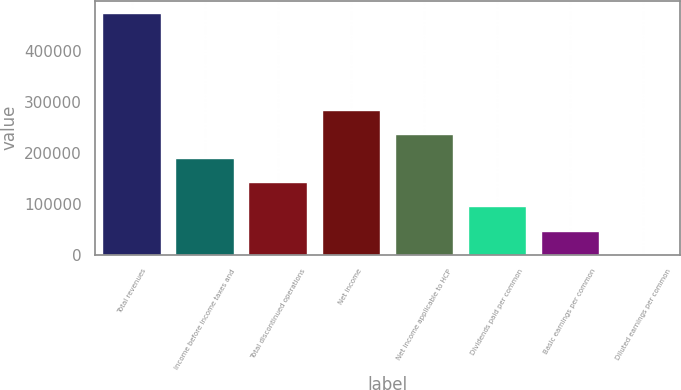Convert chart. <chart><loc_0><loc_0><loc_500><loc_500><bar_chart><fcel>Total revenues<fcel>Income before income taxes and<fcel>Total discontinued operations<fcel>Net income<fcel>Net income applicable to HCP<fcel>Dividends paid per common<fcel>Basic earnings per common<fcel>Diluted earnings per common<nl><fcel>475157<fcel>190063<fcel>142547<fcel>285094<fcel>237579<fcel>95031.8<fcel>47516.1<fcel>0.45<nl></chart> 